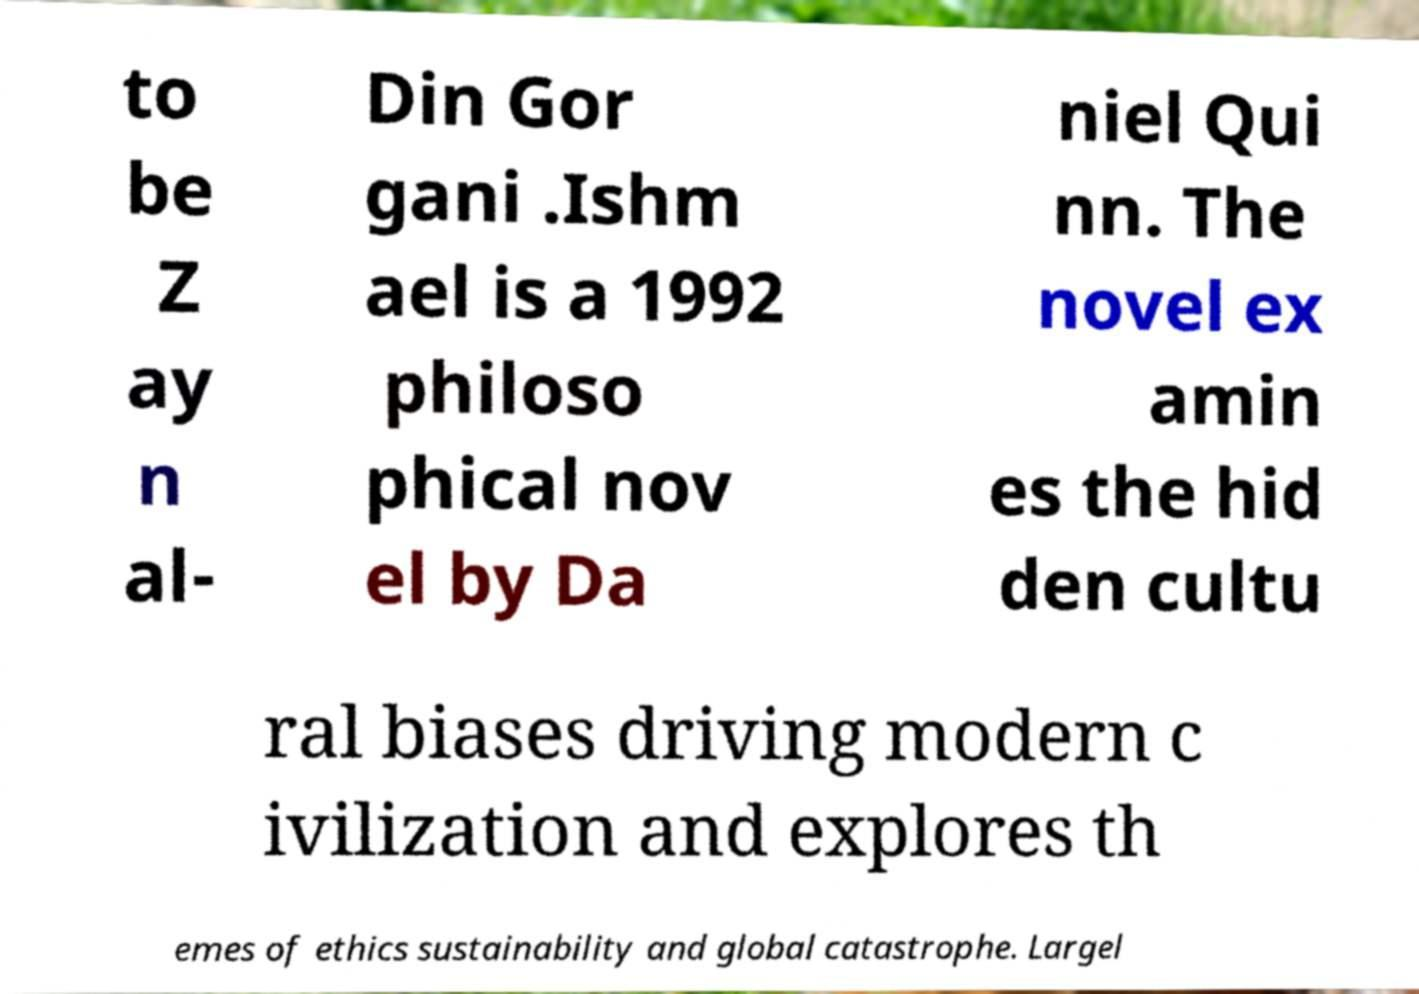Could you assist in decoding the text presented in this image and type it out clearly? to be Z ay n al- Din Gor gani .Ishm ael is a 1992 philoso phical nov el by Da niel Qui nn. The novel ex amin es the hid den cultu ral biases driving modern c ivilization and explores th emes of ethics sustainability and global catastrophe. Largel 